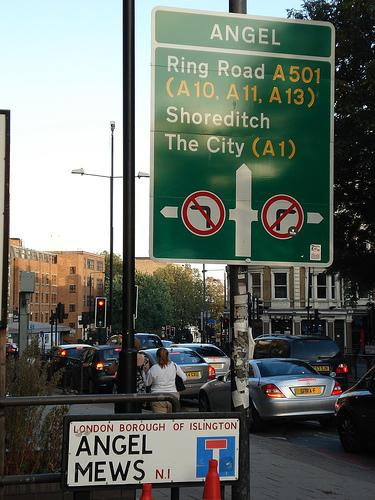What do you notice about the street lamp in the image? The street lamp is tall and seems to be mounted on a metal pole. What is the overall ambiance or mood depicted in the image? The mood seems to be lively and bustling, as it captures a busy urban scene with various vehicles, people, and buildings. Identify the different types of signs mentioned in the image's description. There are road signs labeled "angel", "london borough of islington", "ring road", "shoreditch", and "the city a1". Describe the appearance and attire of one person in the image. A woman is wearing a white shirt and appears to be carrying a bag. What objects in the image appear to be providing light? Traffic lights, rear lights of cars, and a street lamp are objects providing light in the image. Can you tell me what color are the rear lights of the cars in the picture? The rear lights of the cars are red. Is there a particular meeting point or address mentioned in the image description? No specific meeting point or address is mentioned in the image description. What is the predominant color of the traffic cones in the image? The traffic cones are predominantly red. Briefly describe the scene being depicted in the image. The image shows a busy city street with cars, traffic lights, street signs, and pedestrians, including a woman in a white shirt. Is there a traffic sign showing an airport symbol? No, it's not mentioned in the image. 